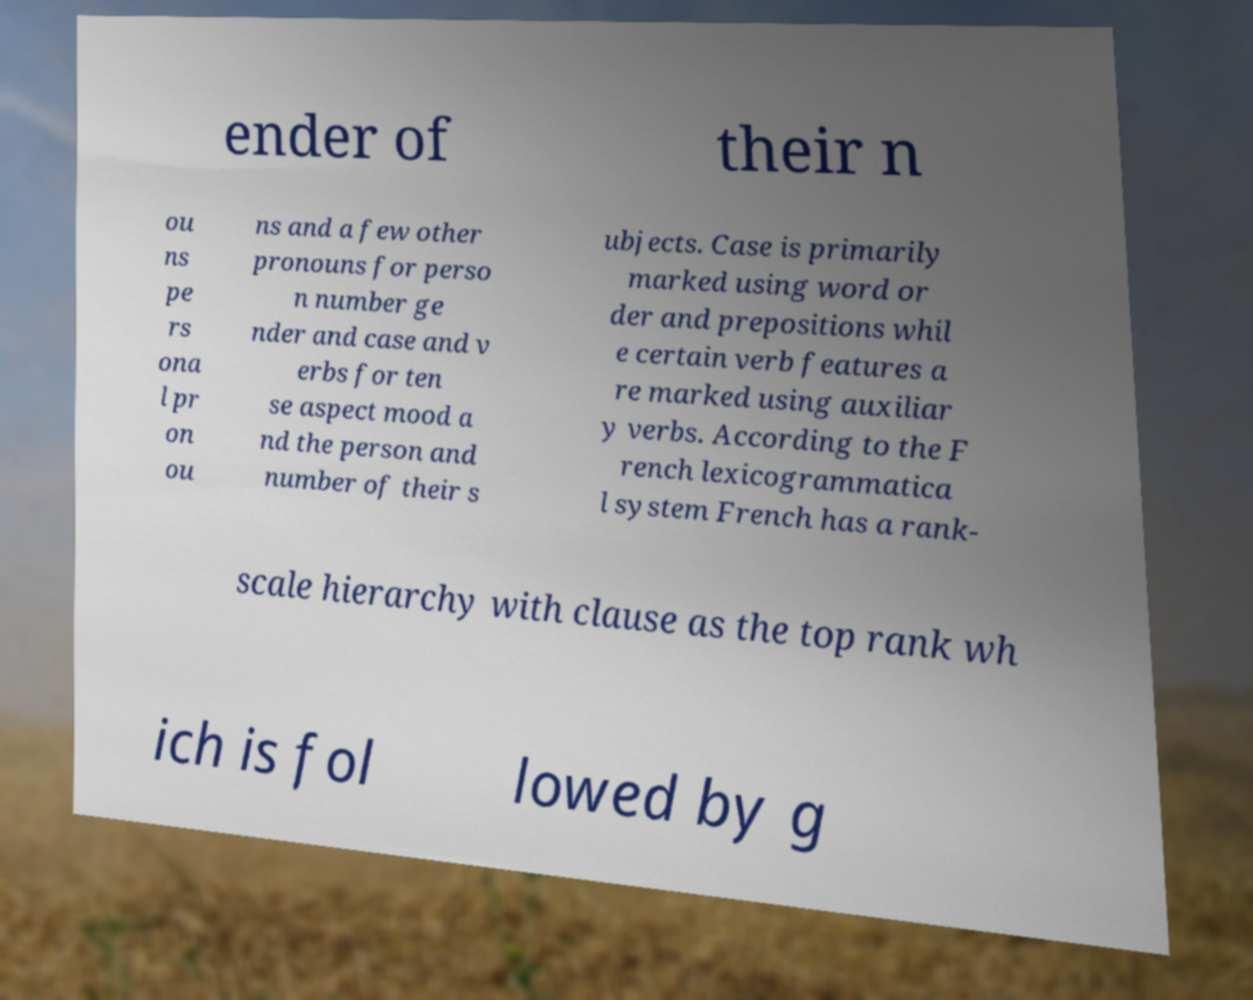I need the written content from this picture converted into text. Can you do that? ender of their n ou ns pe rs ona l pr on ou ns and a few other pronouns for perso n number ge nder and case and v erbs for ten se aspect mood a nd the person and number of their s ubjects. Case is primarily marked using word or der and prepositions whil e certain verb features a re marked using auxiliar y verbs. According to the F rench lexicogrammatica l system French has a rank- scale hierarchy with clause as the top rank wh ich is fol lowed by g 